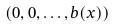<formula> <loc_0><loc_0><loc_500><loc_500>( 0 , 0 , \dots , b ( x ) )</formula> 